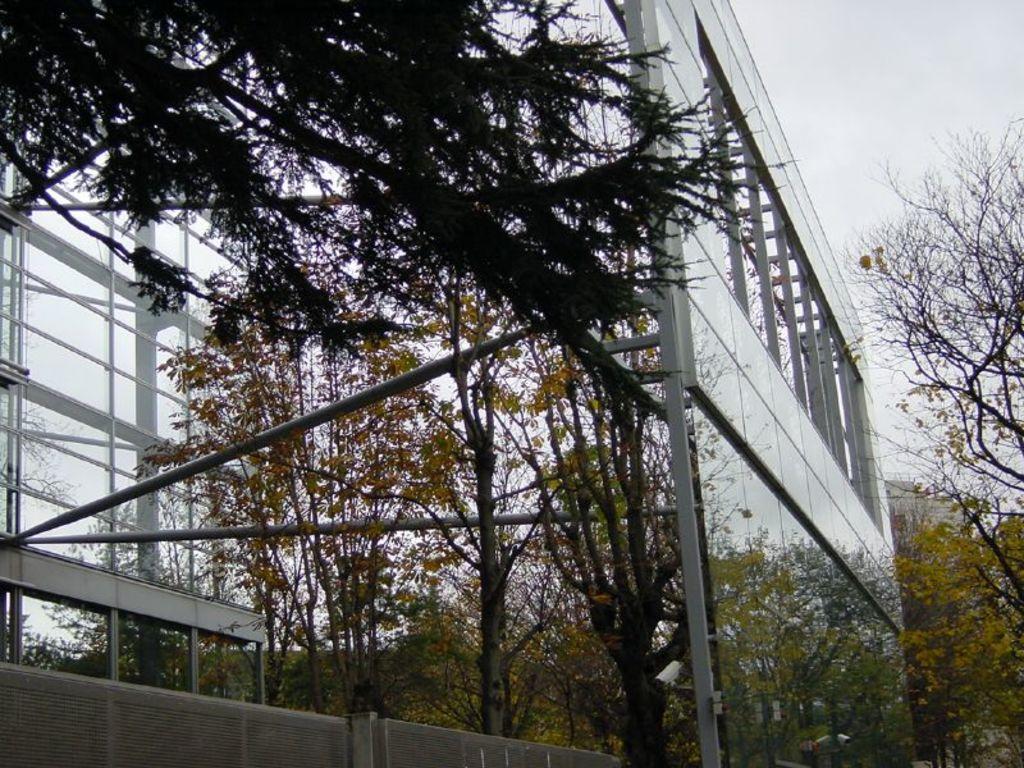In one or two sentences, can you explain what this image depicts? In this picture, we the glass wall with poles and some objects attached, trees, fencing, and the sky. 